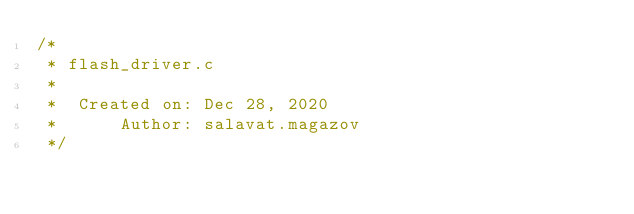Convert code to text. <code><loc_0><loc_0><loc_500><loc_500><_C_>/*
 * flash_driver.c
 *
 *  Created on: Dec 28, 2020
 *      Author: salavat.magazov
 */
</code> 